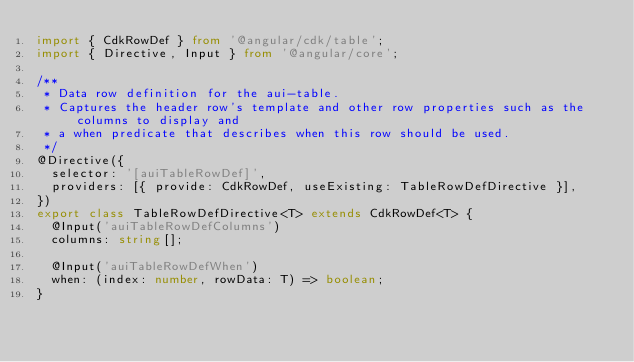Convert code to text. <code><loc_0><loc_0><loc_500><loc_500><_TypeScript_>import { CdkRowDef } from '@angular/cdk/table';
import { Directive, Input } from '@angular/core';

/**
 * Data row definition for the aui-table.
 * Captures the header row's template and other row properties such as the columns to display and
 * a when predicate that describes when this row should be used.
 */
@Directive({
  selector: '[auiTableRowDef]',
  providers: [{ provide: CdkRowDef, useExisting: TableRowDefDirective }],
})
export class TableRowDefDirective<T> extends CdkRowDef<T> {
  @Input('auiTableRowDefColumns')
  columns: string[];

  @Input('auiTableRowDefWhen')
  when: (index: number, rowData: T) => boolean;
}
</code> 